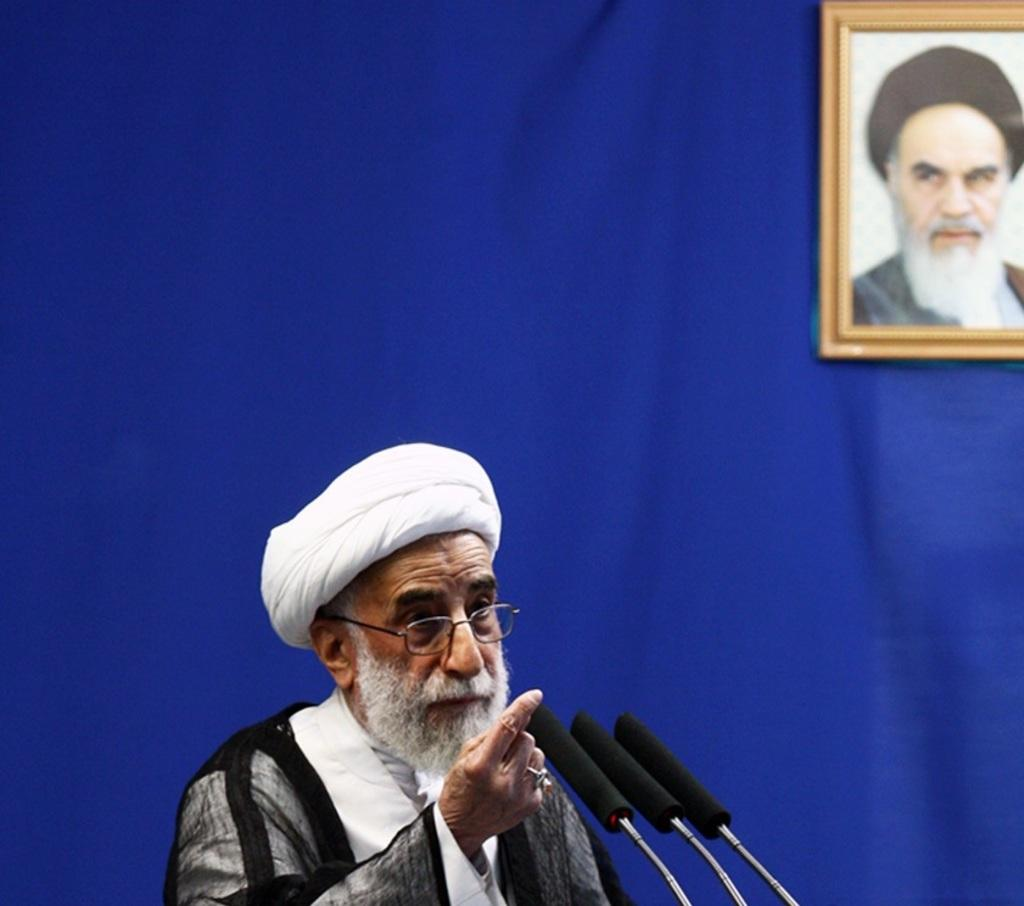Who is present in the image? There is a man in the image. What is the man doing in the image? The man is talking near a microphone. What can be seen in the background of the image? There is a blue curtain wall in the image. What is attached to the blue curtain wall? There is a photo frame on the blue curtain wall. Who is depicted in the photograph inside the photo frame? There is a photograph of a person in the photo frame. What color is the ink used to write the speech the man is delivering in the image? There is no information about the speech or ink color in the image. Is there a fireman present in the image? No, there is no fireman present in the image. 